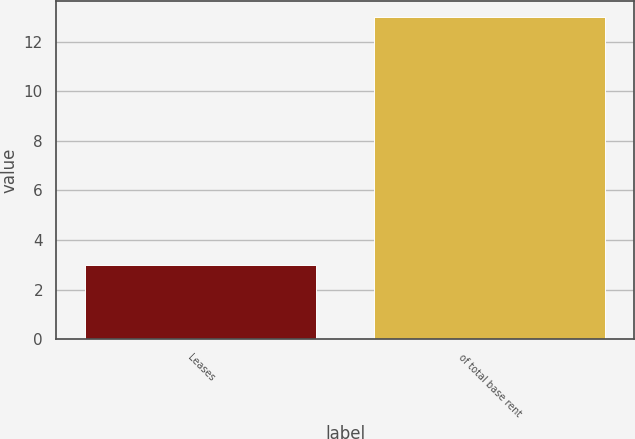Convert chart to OTSL. <chart><loc_0><loc_0><loc_500><loc_500><bar_chart><fcel>Leases<fcel>of total base rent<nl><fcel>3<fcel>13<nl></chart> 